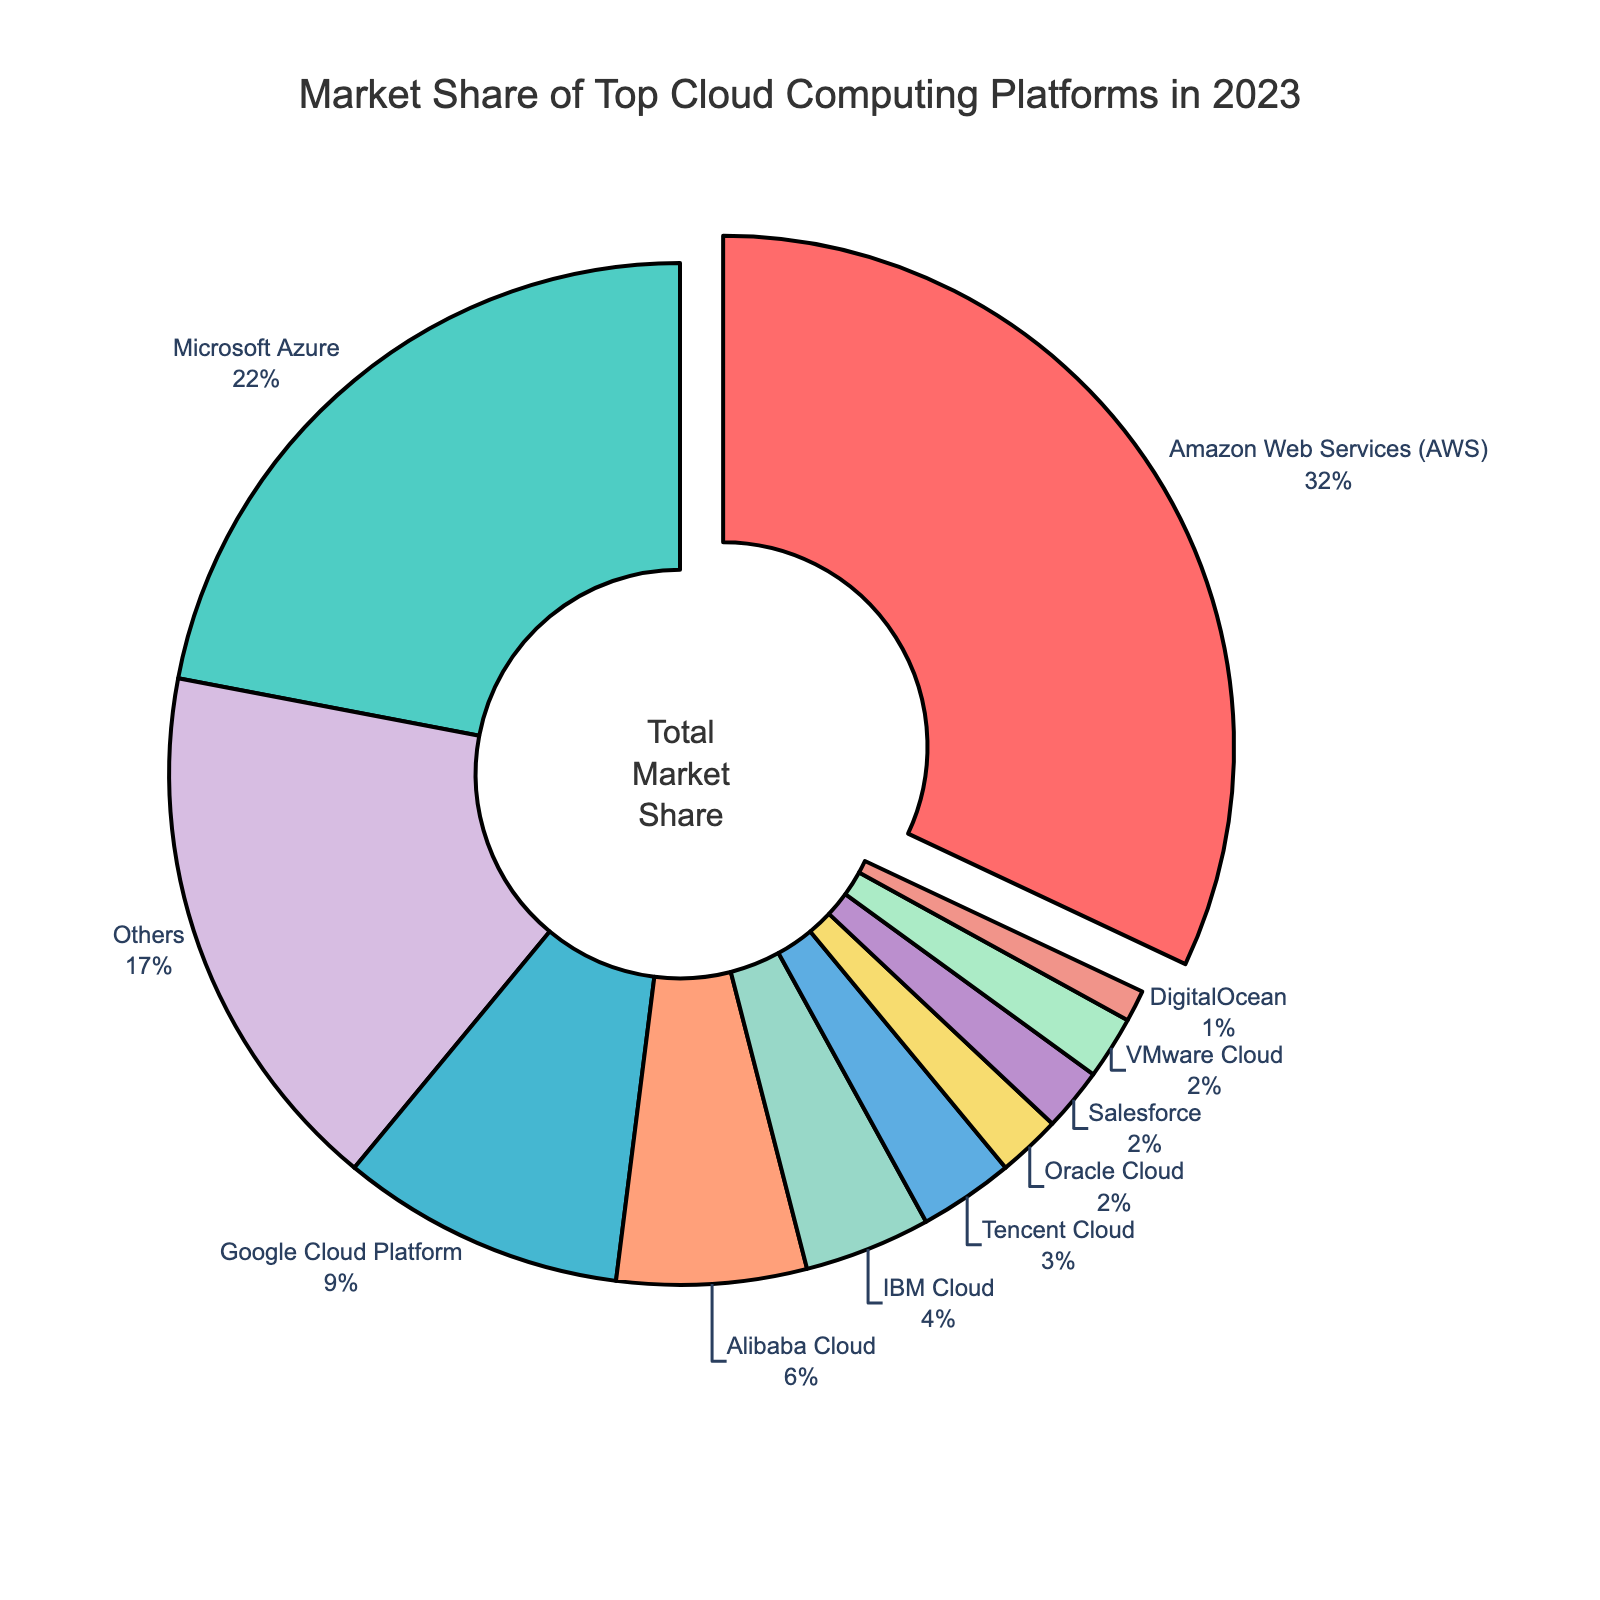What is the market share of Amazon Web Services (AWS)? According to the pie chart, Amazon Web Services (AWS) holds 32% of the market share. The chart visually indicates this with a significant segment labeled "AWS".
Answer: 32% What is the total market share of the platforms with less than 5% share each? From the chart, the platforms with less than 5% share are IBM Cloud (4%), Oracle Cloud (2%), Salesforce (2%), Tencent Cloud (3%), DigitalOcean (1%), and VMware Cloud (2%). Adding these together: 4+2+2+3+1+2 = 14%.
Answer: 14% Which cloud provider has the second largest market share? The chart clearly shows Microsoft Azure as the second largest segment after AWS, with a market share of 22%.
Answer: Microsoft Azure What is the combined market share of Google Cloud Platform and Alibaba Cloud? Google Cloud Platform has a 9% share and Alibaba Cloud has a 6% share. Combining these: 9 + 6 = 15%.
Answer: 15% How much greater is Amazon Web Services' market share compared to Google Cloud Platform's? AWS has 32% of the market share, while Google Cloud Platform has 9%. The difference is 32 - 9 = 23%.
Answer: 23% What percentage do other cloud providers (labeled "Others") hold in the market? The chart indicates that the "Others" category holds a 17% share of the market.
Answer: 17% Which cloud providers have the same market share? According to the chart, Oracle Cloud and Salesforce both have a market share of 2%.
Answer: Oracle Cloud and Salesforce What is the total market share of the top three cloud providers? The top three are AWS (32%), Microsoft Azure (22%), and Google Cloud Platform (9%). Adding these: 32 + 22 + 9 = 63%.
Answer: 63% What color is used to represent IBM Cloud in the pie chart? The chart uses a specific color for each cloud provider. IBM Cloud is represented by a yellow segment.
Answer: Yellow How does the market share of Alibaba Cloud compare to that of Tencent Cloud? Alibaba Cloud has a 6% market share, while Tencent Cloud has a 3% market share. Alibaba Cloud's share is twice that of Tencent Cloud.
Answer: Double 